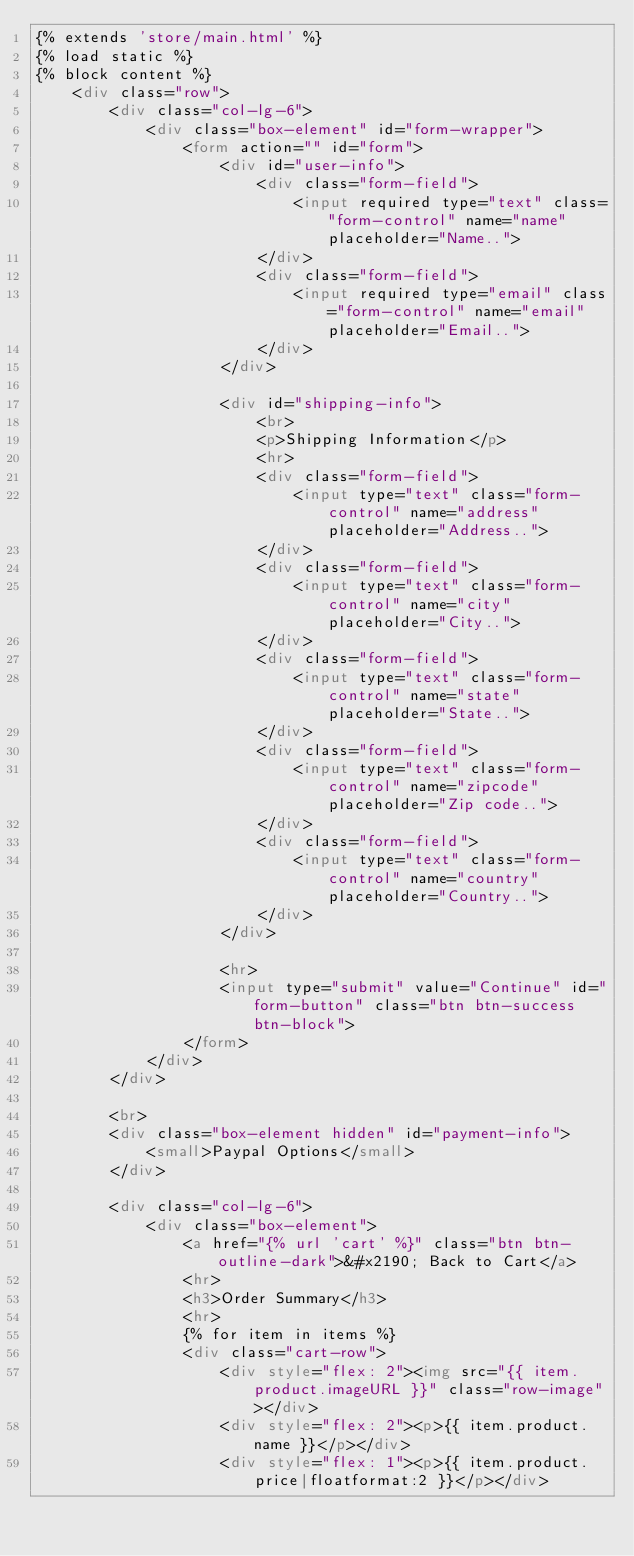Convert code to text. <code><loc_0><loc_0><loc_500><loc_500><_HTML_>{% extends 'store/main.html' %}
{% load static %}
{% block content %}
    <div class="row">
        <div class="col-lg-6">
            <div class="box-element" id="form-wrapper">
                <form action="" id="form">
                    <div id="user-info">
                        <div class="form-field">
                            <input required type="text" class="form-control" name="name" placeholder="Name..">
                        </div>
                        <div class="form-field">
                            <input required type="email" class="form-control" name="email" placeholder="Email..">
                        </div>
                    </div>

                    <div id="shipping-info">
                        <br>
                        <p>Shipping Information</p>
                        <hr>
                        <div class="form-field">
                            <input type="text" class="form-control" name="address" placeholder="Address..">
                        </div>
                        <div class="form-field">
                            <input type="text" class="form-control" name="city" placeholder="City..">
                        </div>
                        <div class="form-field">
                            <input type="text" class="form-control" name="state" placeholder="State..">
                        </div>
                        <div class="form-field">
                            <input type="text" class="form-control" name="zipcode" placeholder="Zip code..">
                        </div>
                        <div class="form-field">
                            <input type="text" class="form-control" name="country" placeholder="Country..">
                        </div>
                    </div>

                    <hr>
                    <input type="submit" value="Continue" id="form-button" class="btn btn-success btn-block">
                </form>
            </div>
        </div>

        <br>
        <div class="box-element hidden" id="payment-info">
            <small>Paypal Options</small>
        </div>

        <div class="col-lg-6">
            <div class="box-element">
                <a href="{% url 'cart' %}" class="btn btn-outline-dark">&#x2190; Back to Cart</a>
                <hr>
                <h3>Order Summary</h3>
                <hr>
                {% for item in items %}
                <div class="cart-row">
                    <div style="flex: 2"><img src="{{ item.product.imageURL }}" class="row-image"></div>
                    <div style="flex: 2"><p>{{ item.product.name }}</p></div>
                    <div style="flex: 1"><p>{{ item.product.price|floatformat:2 }}</p></div></code> 